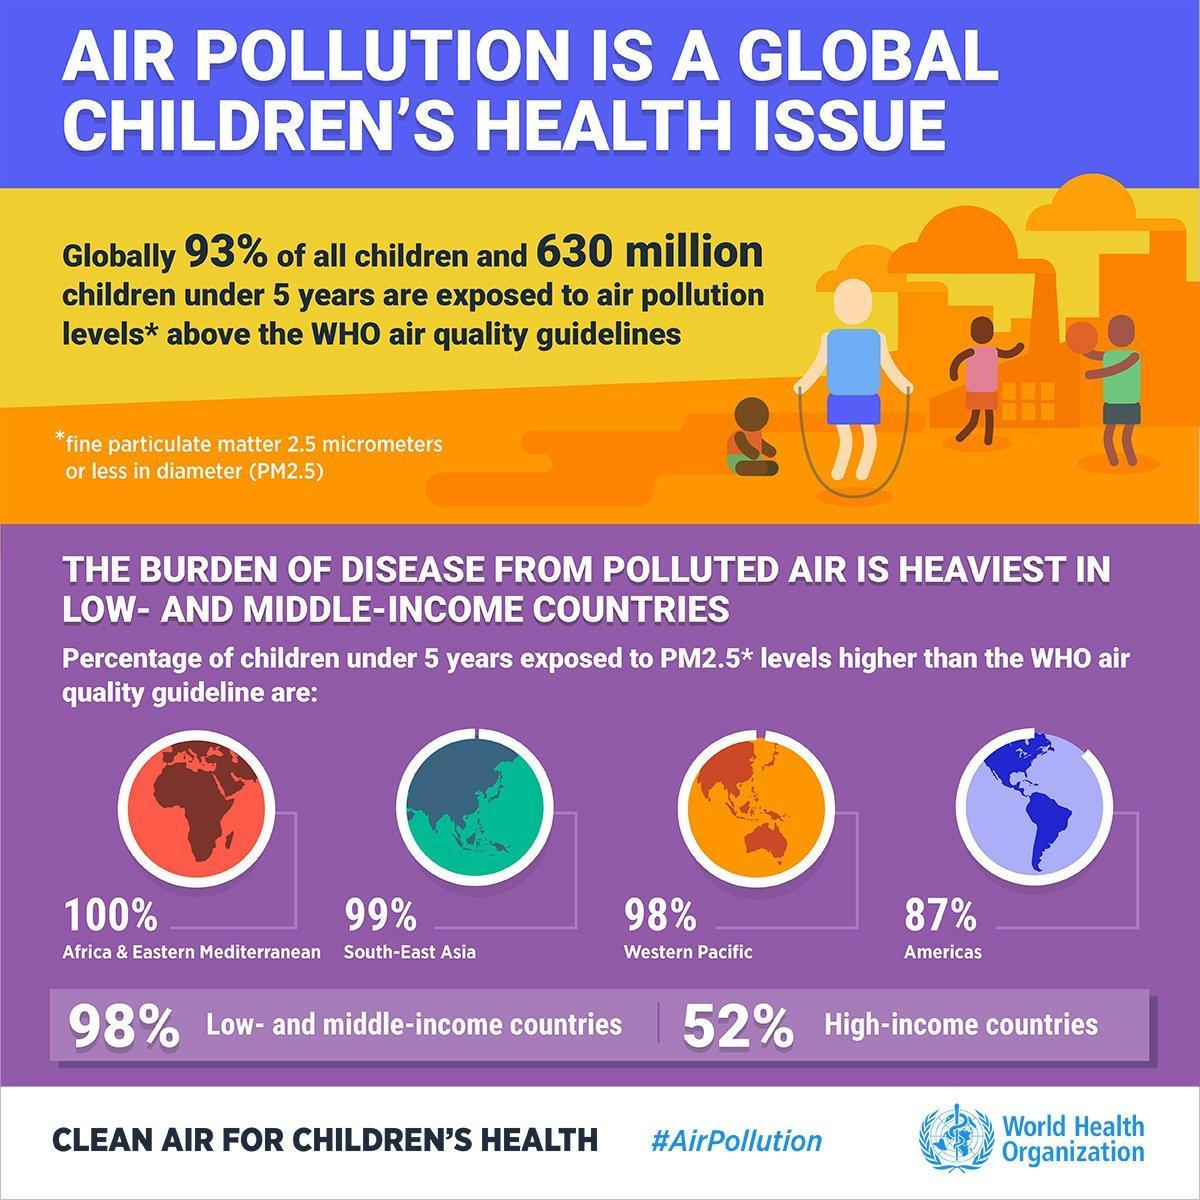What percentage of children in the Western Pacific region under five years not exposed to air pollution?
Answer the question with a short phrase. 2% What percentage of children in America under five years not exposed to air pollution? 13 What percentage of children in High-income countries not exposed to air pollution? 48% What percentage of children under five years not exposed to air pollution? 7% What percentage of children in Low and Middle-income countries not exposed to air pollution? 2% What percentage of children in the South-East Asia region under five years not exposed to air pollution? 1% 